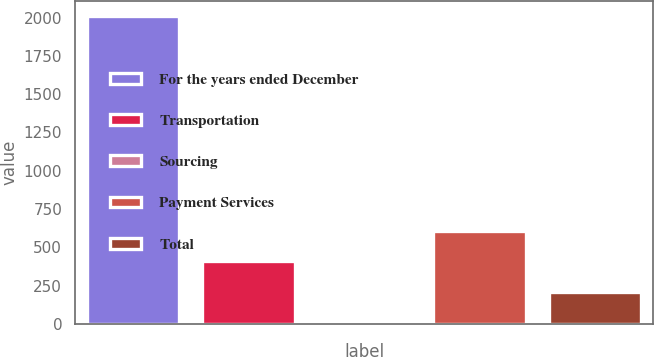Convert chart. <chart><loc_0><loc_0><loc_500><loc_500><bar_chart><fcel>For the years ended December<fcel>Transportation<fcel>Sourcing<fcel>Payment Services<fcel>Total<nl><fcel>2010<fcel>408.8<fcel>8.5<fcel>608.95<fcel>208.65<nl></chart> 